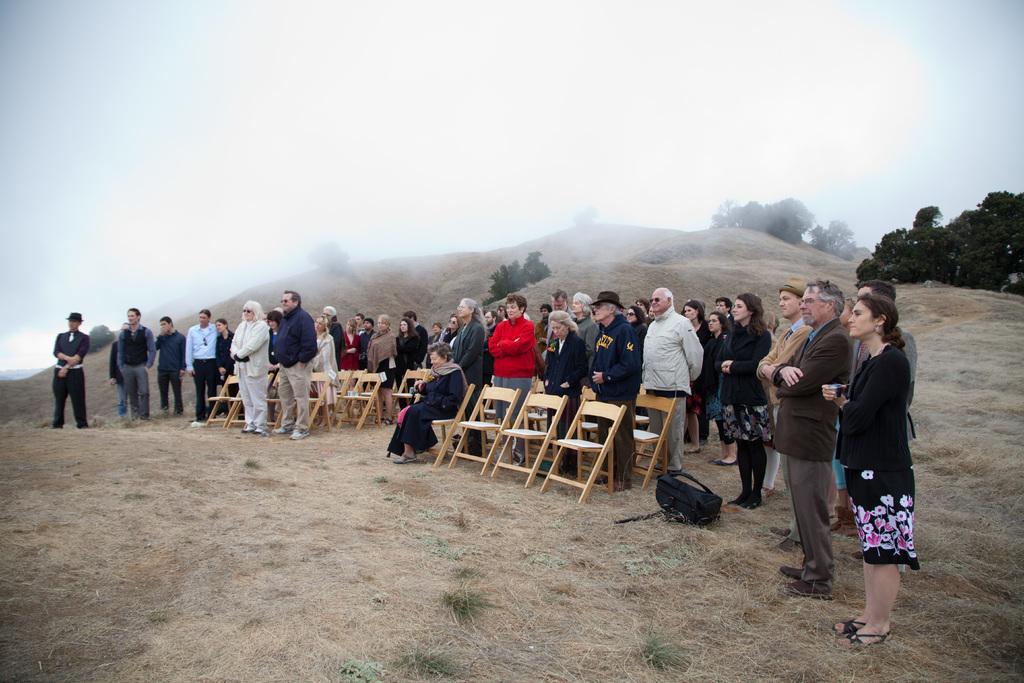In one or two sentences, can you explain what this image depicts? In the image there are many people stood and there is woman in the front sat on chair and they all are on hill and there are some trees on hill above its cloudy over the sky. 